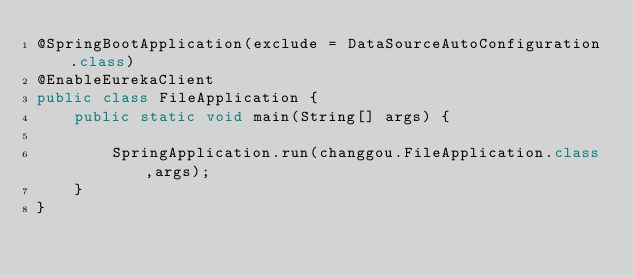Convert code to text. <code><loc_0><loc_0><loc_500><loc_500><_Java_>@SpringBootApplication(exclude = DataSourceAutoConfiguration.class)
@EnableEurekaClient
public class FileApplication {
    public static void main(String[] args) {

        SpringApplication.run(changgou.FileApplication.class,args);
    }
}
</code> 